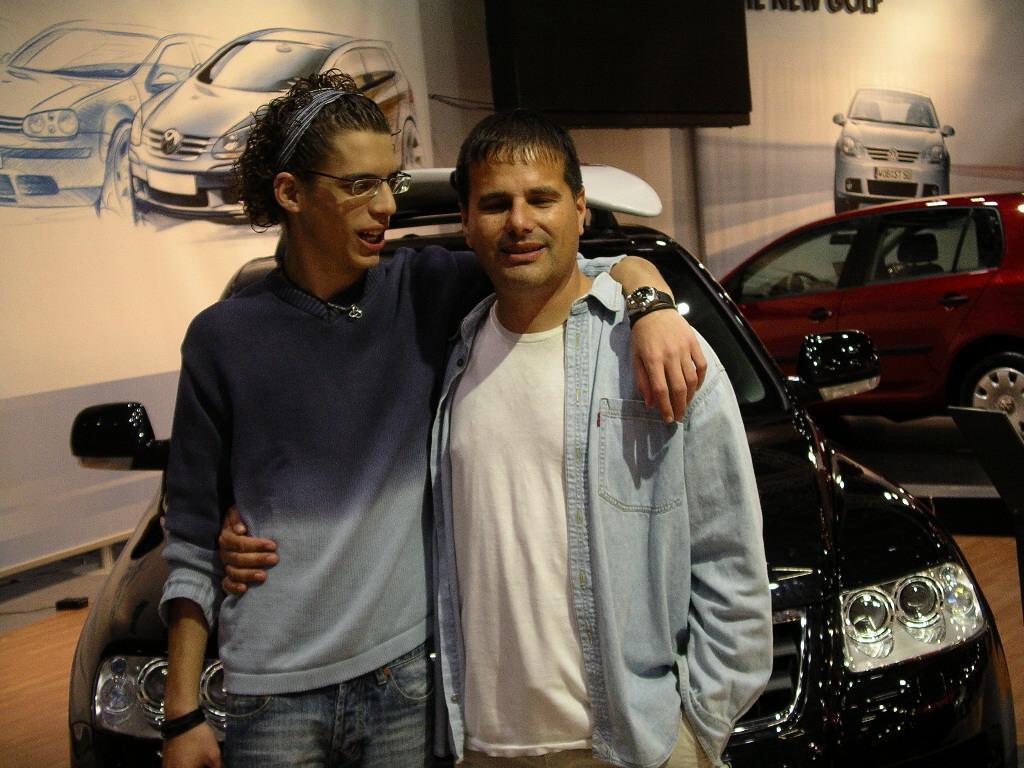How would you summarize this image in a sentence or two? In this image I can see two people with different color dresses. To the right I can see the cars. In the background I can see the screen and boards. 